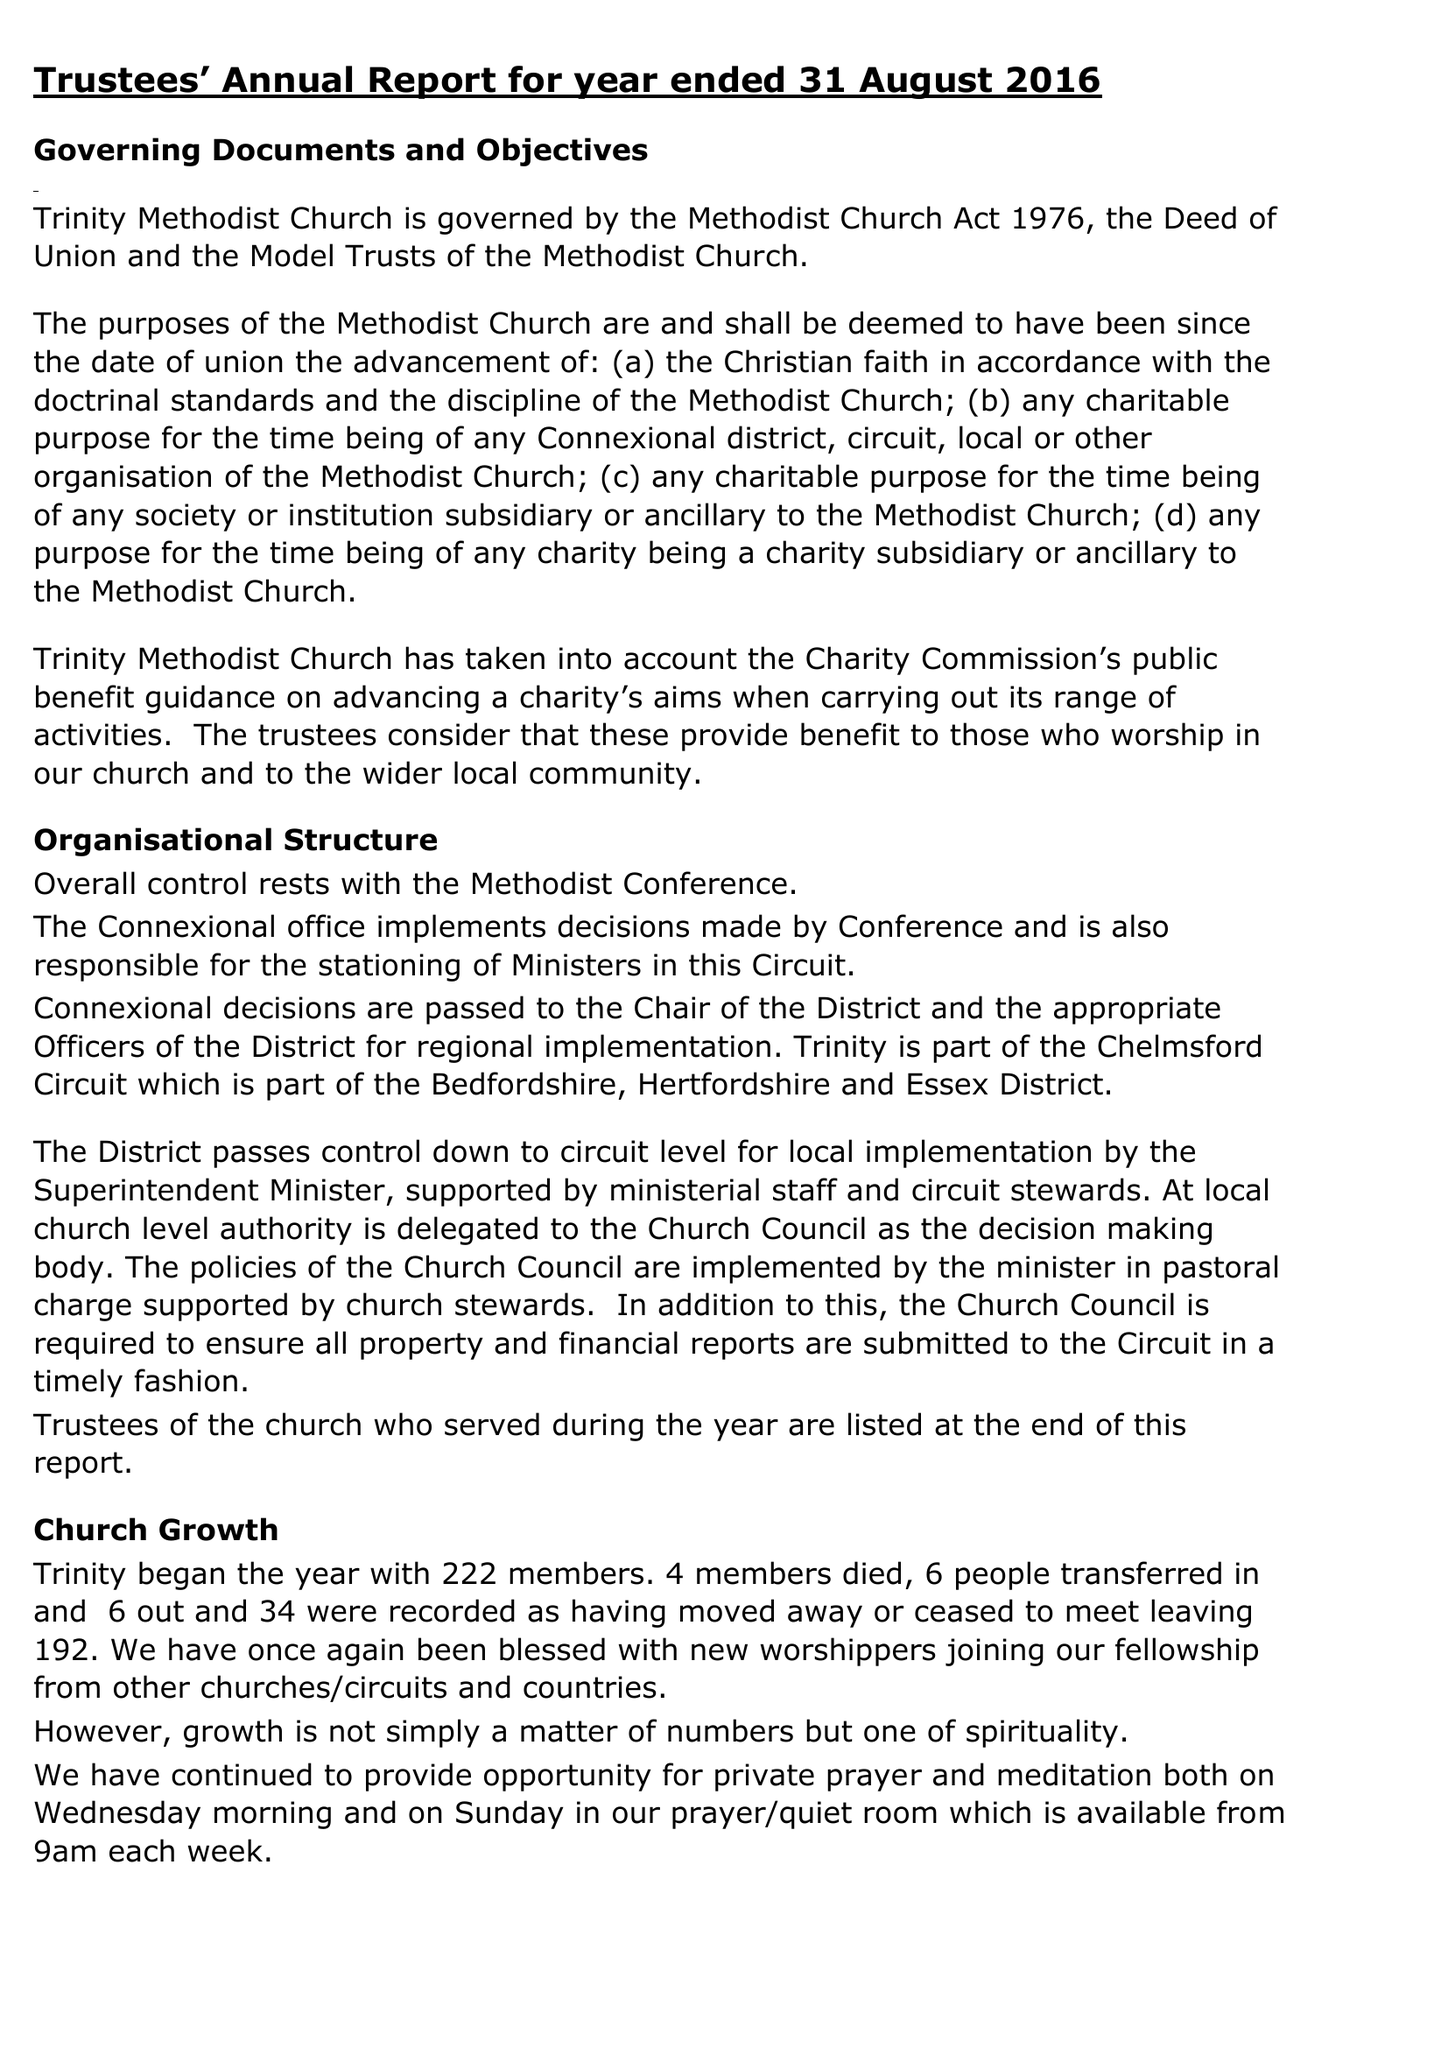What is the value for the address__post_town?
Answer the question using a single word or phrase. CHELMSFORD 